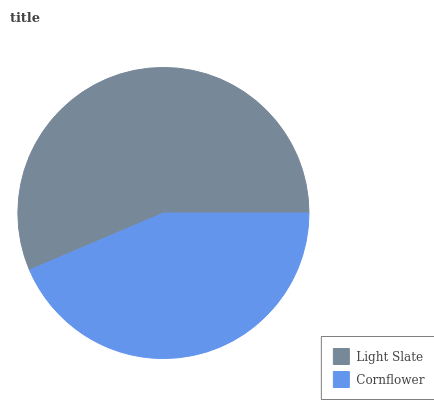Is Cornflower the minimum?
Answer yes or no. Yes. Is Light Slate the maximum?
Answer yes or no. Yes. Is Cornflower the maximum?
Answer yes or no. No. Is Light Slate greater than Cornflower?
Answer yes or no. Yes. Is Cornflower less than Light Slate?
Answer yes or no. Yes. Is Cornflower greater than Light Slate?
Answer yes or no. No. Is Light Slate less than Cornflower?
Answer yes or no. No. Is Light Slate the high median?
Answer yes or no. Yes. Is Cornflower the low median?
Answer yes or no. Yes. Is Cornflower the high median?
Answer yes or no. No. Is Light Slate the low median?
Answer yes or no. No. 